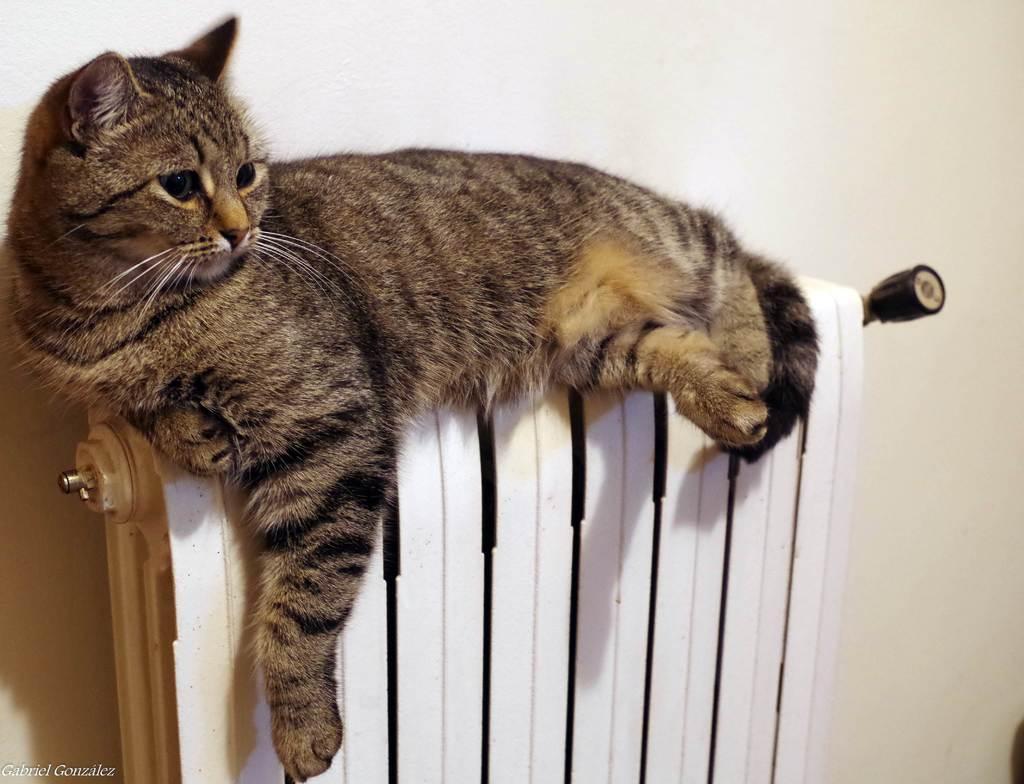Describe this image in one or two sentences. In this image we can see a cat on the radiator with handle. In the bottom we can see some text. 